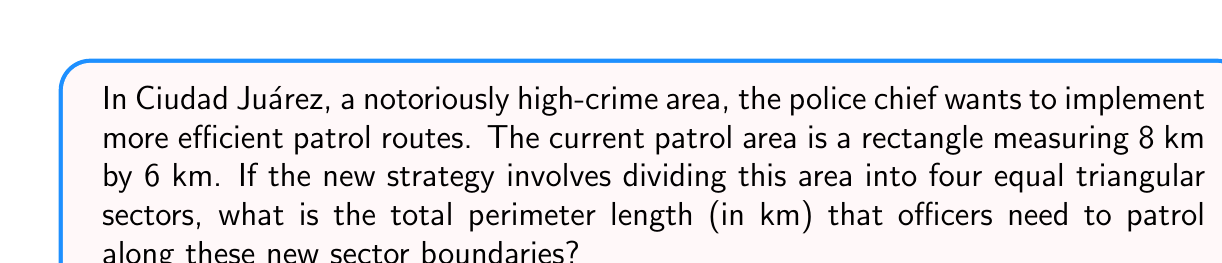Solve this math problem. Let's approach this step-by-step:

1) First, we need to visualize the area:
   [asy]
   size(200);
   draw((0,0)--(8,0)--(8,6)--(0,6)--cycle);
   draw((0,0)--(8,6));
   draw((0,6)--(8,0));
   label("8 km", (4,-0.5));
   label("6 km", (8.5,3));
   [/asy]

2) The rectangle is divided into four triangles by its diagonals.

3) To find the total perimeter, we need to calculate the length of these diagonals.

4) We can use the Pythagorean theorem to find the length of a diagonal:
   $$ d^2 = 8^2 + 6^2 $$
   $$ d^2 = 64 + 36 = 100 $$
   $$ d = \sqrt{100} = 10 \text{ km} $$

5) There are two diagonals, each 10 km long.

6) The total perimeter is the sum of these two diagonals:
   $$ \text{Total perimeter} = 10 \text{ km} + 10 \text{ km} = 20 \text{ km} $$

Therefore, the officers need to patrol a total of 20 km along the new sector boundaries.
Answer: 20 km 